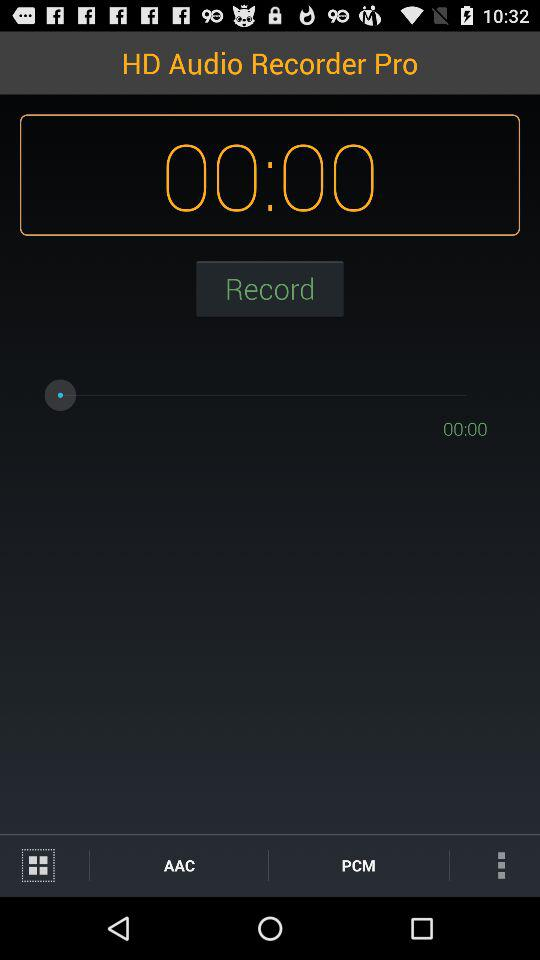How many seconds has the recording been going for?
Answer the question using a single word or phrase. 00:00 